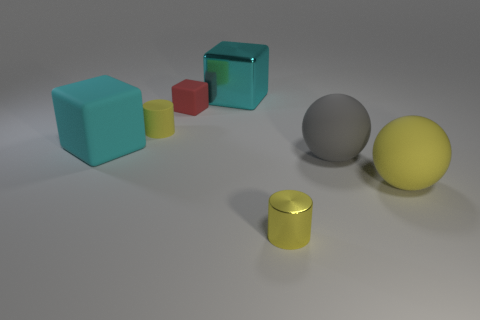Add 1 large cubes. How many objects exist? 8 Subtract all blocks. How many objects are left? 4 Add 4 gray matte objects. How many gray matte objects exist? 5 Subtract 0 green cylinders. How many objects are left? 7 Subtract all matte cylinders. Subtract all matte balls. How many objects are left? 4 Add 1 red things. How many red things are left? 2 